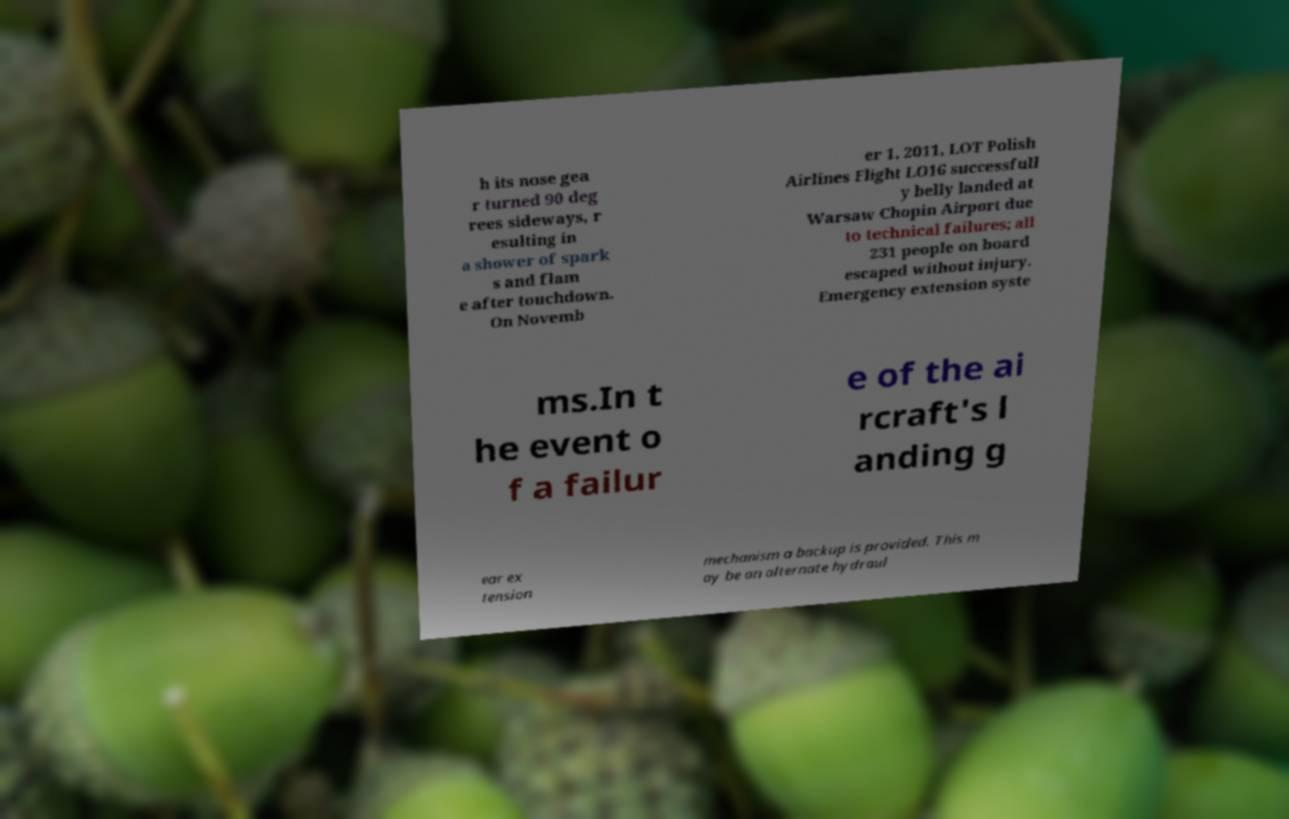Can you read and provide the text displayed in the image?This photo seems to have some interesting text. Can you extract and type it out for me? h its nose gea r turned 90 deg rees sideways, r esulting in a shower of spark s and flam e after touchdown. On Novemb er 1, 2011, LOT Polish Airlines Flight LO16 successfull y belly landed at Warsaw Chopin Airport due to technical failures; all 231 people on board escaped without injury. Emergency extension syste ms.In t he event o f a failur e of the ai rcraft's l anding g ear ex tension mechanism a backup is provided. This m ay be an alternate hydraul 